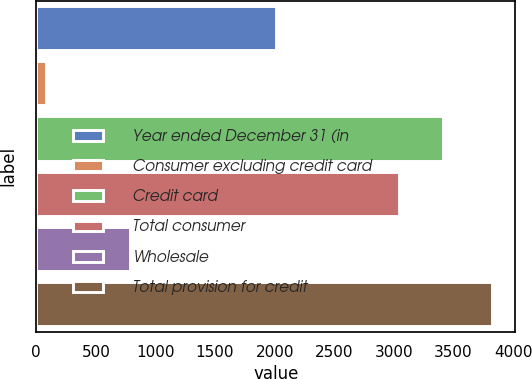Convert chart to OTSL. <chart><loc_0><loc_0><loc_500><loc_500><bar_chart><fcel>Year ended December 31 (in<fcel>Consumer excluding credit card<fcel>Credit card<fcel>Total consumer<fcel>Wholesale<fcel>Total provision for credit<nl><fcel>2015<fcel>81<fcel>3415.6<fcel>3041<fcel>786<fcel>3827<nl></chart> 